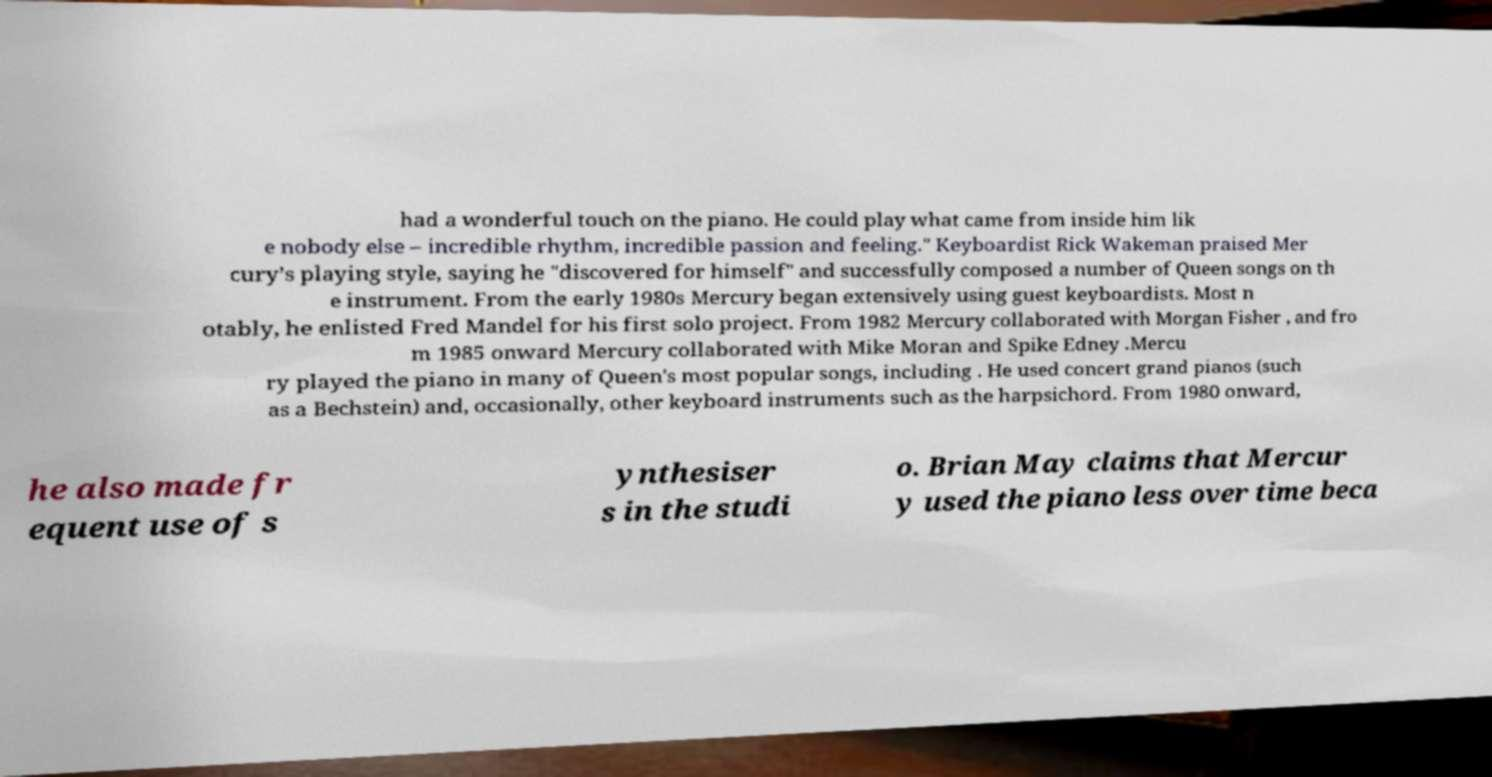I need the written content from this picture converted into text. Can you do that? had a wonderful touch on the piano. He could play what came from inside him lik e nobody else – incredible rhythm, incredible passion and feeling." Keyboardist Rick Wakeman praised Mer cury’s playing style, saying he "discovered for himself" and successfully composed a number of Queen songs on th e instrument. From the early 1980s Mercury began extensively using guest keyboardists. Most n otably, he enlisted Fred Mandel for his first solo project. From 1982 Mercury collaborated with Morgan Fisher , and fro m 1985 onward Mercury collaborated with Mike Moran and Spike Edney .Mercu ry played the piano in many of Queen's most popular songs, including . He used concert grand pianos (such as a Bechstein) and, occasionally, other keyboard instruments such as the harpsichord. From 1980 onward, he also made fr equent use of s ynthesiser s in the studi o. Brian May claims that Mercur y used the piano less over time beca 